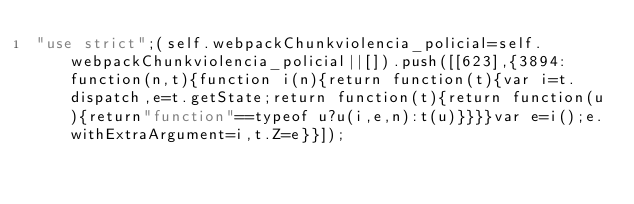<code> <loc_0><loc_0><loc_500><loc_500><_JavaScript_>"use strict";(self.webpackChunkviolencia_policial=self.webpackChunkviolencia_policial||[]).push([[623],{3894:function(n,t){function i(n){return function(t){var i=t.dispatch,e=t.getState;return function(t){return function(u){return"function"==typeof u?u(i,e,n):t(u)}}}}var e=i();e.withExtraArgument=i,t.Z=e}}]);</code> 